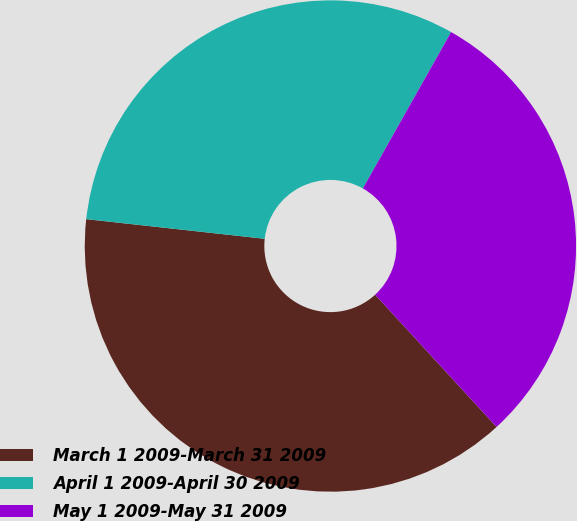Convert chart to OTSL. <chart><loc_0><loc_0><loc_500><loc_500><pie_chart><fcel>March 1 2009-March 31 2009<fcel>April 1 2009-April 30 2009<fcel>May 1 2009-May 31 2009<nl><fcel>38.57%<fcel>31.43%<fcel>30.0%<nl></chart> 